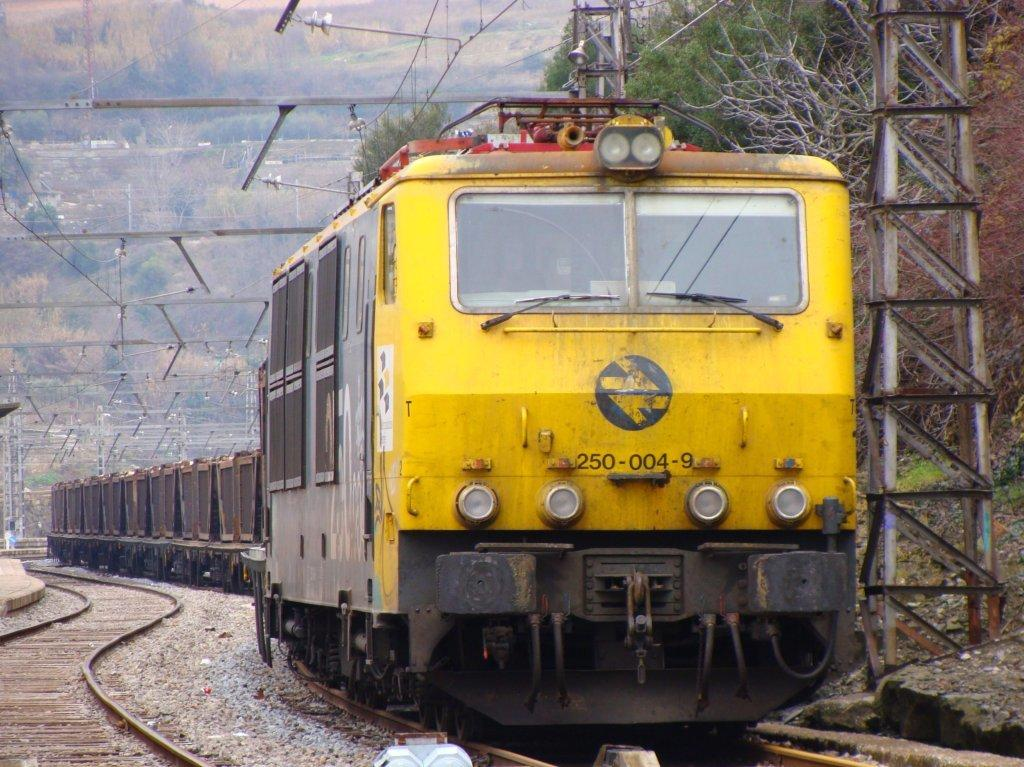Provide a one-sentence caption for the provided image. Yellow train going down the tracks with the number 2500049 on the front. 